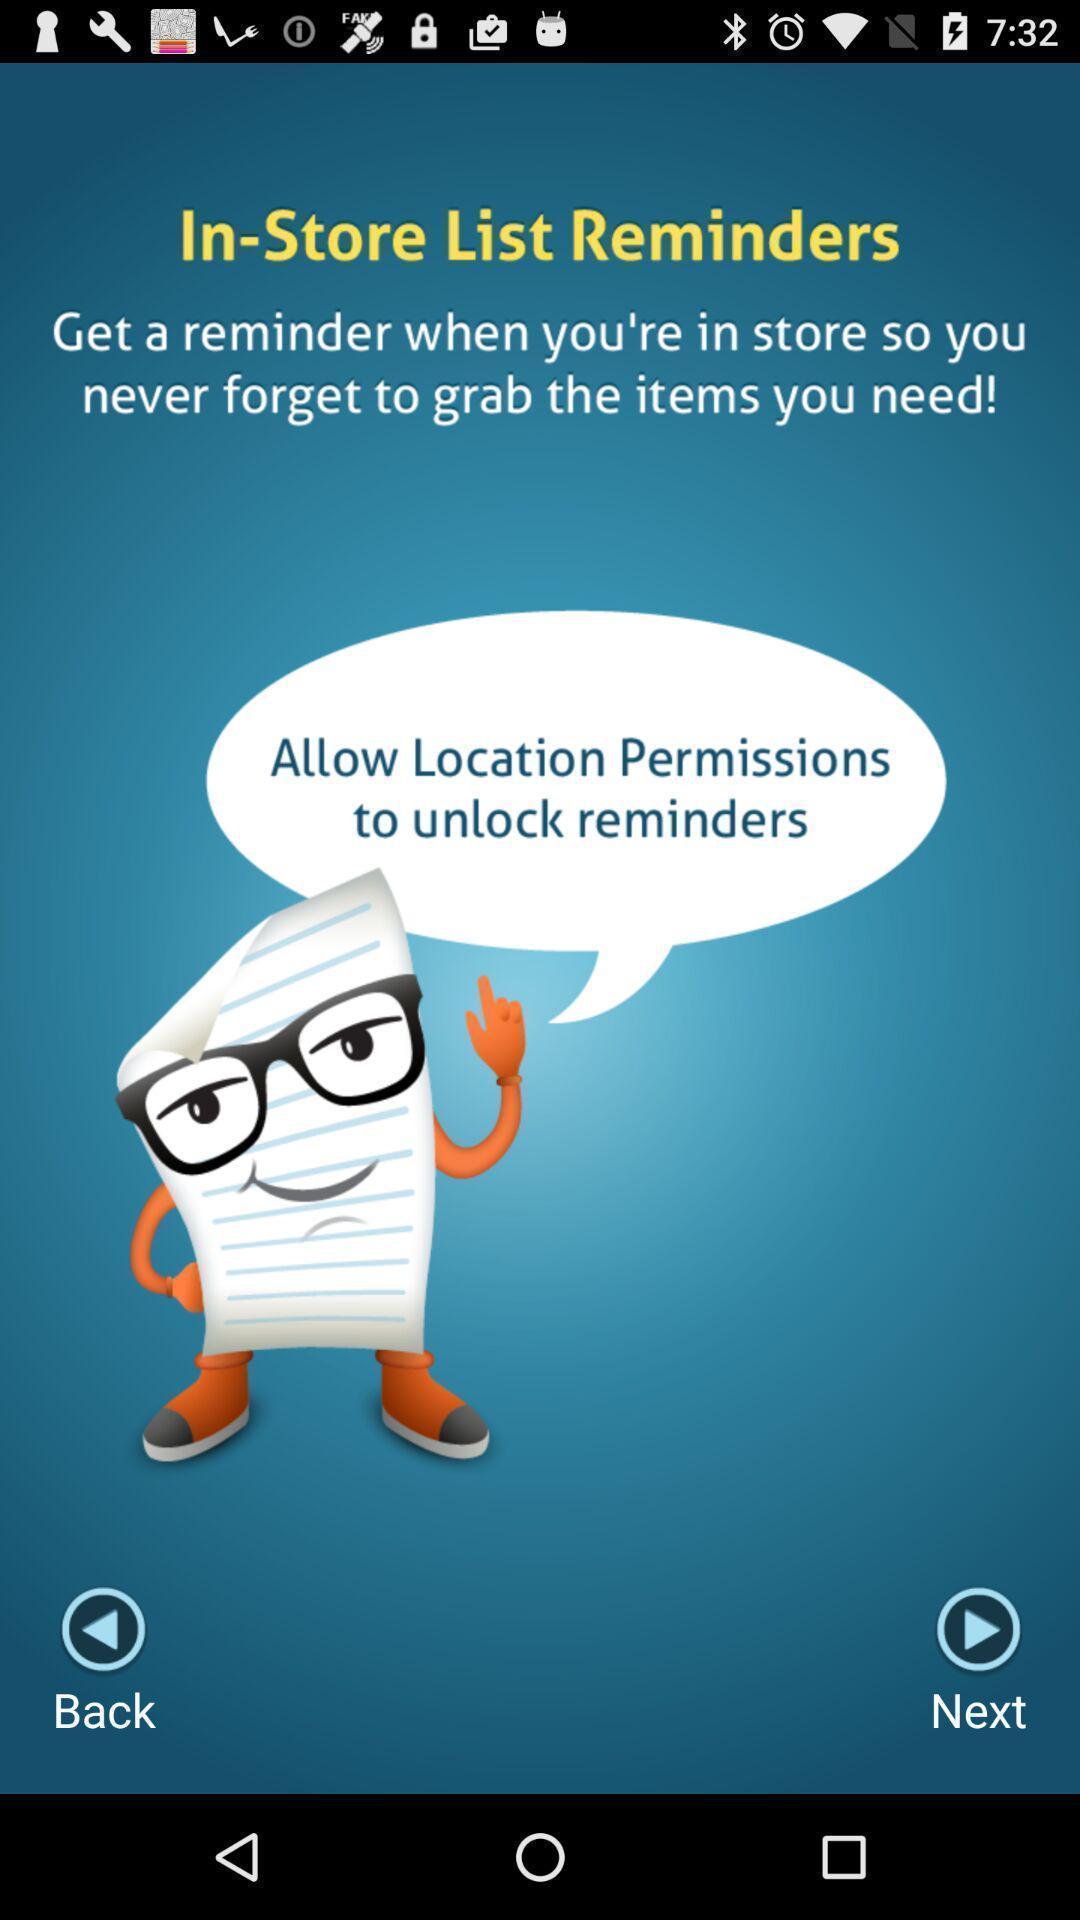Describe this image in words. Welcome page of an alerts app. 